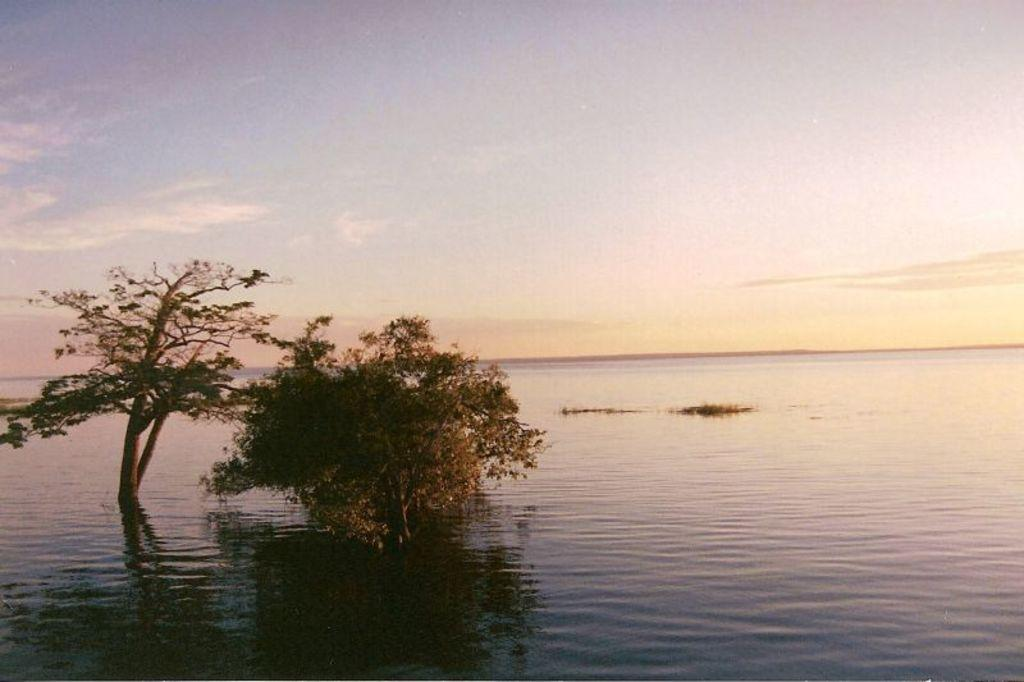What is present at the bottom of the image? There is water at the bottom of the image. What can be seen in the middle of the image? There are two trees in the middle of the image. What is visible at the top of the image? The sky is visible at the top of the image. What reason does the turkey have for being in the image? There is no turkey present in the image, so it cannot have a reason for being there. Is there any payment required to view the image? The image is not a product or service, so there is no payment required to view it. 